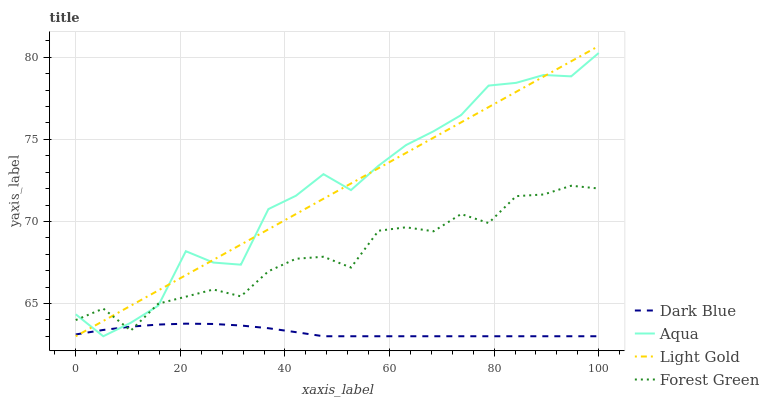Does Dark Blue have the minimum area under the curve?
Answer yes or no. Yes. Does Aqua have the maximum area under the curve?
Answer yes or no. Yes. Does Forest Green have the minimum area under the curve?
Answer yes or no. No. Does Forest Green have the maximum area under the curve?
Answer yes or no. No. Is Light Gold the smoothest?
Answer yes or no. Yes. Is Aqua the roughest?
Answer yes or no. Yes. Is Forest Green the smoothest?
Answer yes or no. No. Is Forest Green the roughest?
Answer yes or no. No. Does Forest Green have the lowest value?
Answer yes or no. No. Does Light Gold have the highest value?
Answer yes or no. Yes. Does Forest Green have the highest value?
Answer yes or no. No. Does Dark Blue intersect Forest Green?
Answer yes or no. Yes. Is Dark Blue less than Forest Green?
Answer yes or no. No. Is Dark Blue greater than Forest Green?
Answer yes or no. No. 